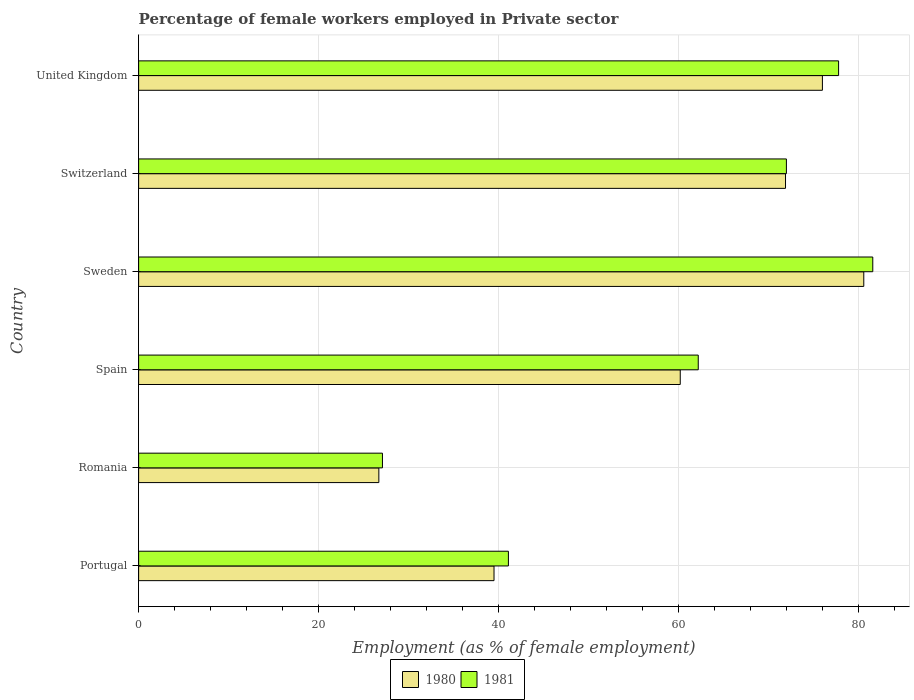How many groups of bars are there?
Give a very brief answer. 6. Are the number of bars on each tick of the Y-axis equal?
Your response must be concise. Yes. How many bars are there on the 3rd tick from the bottom?
Keep it short and to the point. 2. What is the label of the 5th group of bars from the top?
Provide a succinct answer. Romania. Across all countries, what is the maximum percentage of females employed in Private sector in 1981?
Offer a very short reply. 81.6. Across all countries, what is the minimum percentage of females employed in Private sector in 1981?
Ensure brevity in your answer.  27.1. In which country was the percentage of females employed in Private sector in 1980 maximum?
Provide a short and direct response. Sweden. In which country was the percentage of females employed in Private sector in 1981 minimum?
Your answer should be very brief. Romania. What is the total percentage of females employed in Private sector in 1980 in the graph?
Keep it short and to the point. 354.9. What is the difference between the percentage of females employed in Private sector in 1981 in Switzerland and that in United Kingdom?
Provide a succinct answer. -5.8. What is the difference between the percentage of females employed in Private sector in 1981 in Romania and the percentage of females employed in Private sector in 1980 in United Kingdom?
Offer a very short reply. -48.9. What is the average percentage of females employed in Private sector in 1980 per country?
Your response must be concise. 59.15. What is the difference between the percentage of females employed in Private sector in 1981 and percentage of females employed in Private sector in 1980 in Romania?
Provide a short and direct response. 0.4. In how many countries, is the percentage of females employed in Private sector in 1980 greater than 72 %?
Your answer should be compact. 2. What is the ratio of the percentage of females employed in Private sector in 1981 in Romania to that in United Kingdom?
Your response must be concise. 0.35. Is the difference between the percentage of females employed in Private sector in 1981 in Spain and Sweden greater than the difference between the percentage of females employed in Private sector in 1980 in Spain and Sweden?
Provide a succinct answer. Yes. What is the difference between the highest and the second highest percentage of females employed in Private sector in 1980?
Your response must be concise. 4.6. What is the difference between the highest and the lowest percentage of females employed in Private sector in 1980?
Your answer should be very brief. 53.9. In how many countries, is the percentage of females employed in Private sector in 1981 greater than the average percentage of females employed in Private sector in 1981 taken over all countries?
Make the answer very short. 4. What does the 1st bar from the bottom in Romania represents?
Your answer should be compact. 1980. How many bars are there?
Your answer should be very brief. 12. Are all the bars in the graph horizontal?
Ensure brevity in your answer.  Yes. How many countries are there in the graph?
Ensure brevity in your answer.  6. What is the difference between two consecutive major ticks on the X-axis?
Your answer should be very brief. 20. Does the graph contain any zero values?
Keep it short and to the point. No. Does the graph contain grids?
Your response must be concise. Yes. Where does the legend appear in the graph?
Give a very brief answer. Bottom center. How are the legend labels stacked?
Your answer should be compact. Horizontal. What is the title of the graph?
Make the answer very short. Percentage of female workers employed in Private sector. Does "2001" appear as one of the legend labels in the graph?
Your answer should be very brief. No. What is the label or title of the X-axis?
Ensure brevity in your answer.  Employment (as % of female employment). What is the Employment (as % of female employment) of 1980 in Portugal?
Offer a terse response. 39.5. What is the Employment (as % of female employment) of 1981 in Portugal?
Give a very brief answer. 41.1. What is the Employment (as % of female employment) in 1980 in Romania?
Provide a succinct answer. 26.7. What is the Employment (as % of female employment) of 1981 in Romania?
Offer a very short reply. 27.1. What is the Employment (as % of female employment) of 1980 in Spain?
Provide a short and direct response. 60.2. What is the Employment (as % of female employment) of 1981 in Spain?
Keep it short and to the point. 62.2. What is the Employment (as % of female employment) of 1980 in Sweden?
Offer a terse response. 80.6. What is the Employment (as % of female employment) of 1981 in Sweden?
Your response must be concise. 81.6. What is the Employment (as % of female employment) of 1980 in Switzerland?
Make the answer very short. 71.9. What is the Employment (as % of female employment) in 1980 in United Kingdom?
Ensure brevity in your answer.  76. What is the Employment (as % of female employment) of 1981 in United Kingdom?
Ensure brevity in your answer.  77.8. Across all countries, what is the maximum Employment (as % of female employment) in 1980?
Offer a terse response. 80.6. Across all countries, what is the maximum Employment (as % of female employment) of 1981?
Keep it short and to the point. 81.6. Across all countries, what is the minimum Employment (as % of female employment) in 1980?
Provide a succinct answer. 26.7. Across all countries, what is the minimum Employment (as % of female employment) of 1981?
Your answer should be compact. 27.1. What is the total Employment (as % of female employment) in 1980 in the graph?
Offer a very short reply. 354.9. What is the total Employment (as % of female employment) of 1981 in the graph?
Make the answer very short. 361.8. What is the difference between the Employment (as % of female employment) of 1981 in Portugal and that in Romania?
Ensure brevity in your answer.  14. What is the difference between the Employment (as % of female employment) in 1980 in Portugal and that in Spain?
Your answer should be very brief. -20.7. What is the difference between the Employment (as % of female employment) of 1981 in Portugal and that in Spain?
Make the answer very short. -21.1. What is the difference between the Employment (as % of female employment) in 1980 in Portugal and that in Sweden?
Offer a terse response. -41.1. What is the difference between the Employment (as % of female employment) in 1981 in Portugal and that in Sweden?
Give a very brief answer. -40.5. What is the difference between the Employment (as % of female employment) in 1980 in Portugal and that in Switzerland?
Provide a succinct answer. -32.4. What is the difference between the Employment (as % of female employment) of 1981 in Portugal and that in Switzerland?
Provide a short and direct response. -30.9. What is the difference between the Employment (as % of female employment) of 1980 in Portugal and that in United Kingdom?
Give a very brief answer. -36.5. What is the difference between the Employment (as % of female employment) in 1981 in Portugal and that in United Kingdom?
Provide a succinct answer. -36.7. What is the difference between the Employment (as % of female employment) in 1980 in Romania and that in Spain?
Your response must be concise. -33.5. What is the difference between the Employment (as % of female employment) of 1981 in Romania and that in Spain?
Provide a short and direct response. -35.1. What is the difference between the Employment (as % of female employment) in 1980 in Romania and that in Sweden?
Your answer should be compact. -53.9. What is the difference between the Employment (as % of female employment) of 1981 in Romania and that in Sweden?
Give a very brief answer. -54.5. What is the difference between the Employment (as % of female employment) of 1980 in Romania and that in Switzerland?
Your answer should be compact. -45.2. What is the difference between the Employment (as % of female employment) in 1981 in Romania and that in Switzerland?
Keep it short and to the point. -44.9. What is the difference between the Employment (as % of female employment) of 1980 in Romania and that in United Kingdom?
Offer a very short reply. -49.3. What is the difference between the Employment (as % of female employment) in 1981 in Romania and that in United Kingdom?
Provide a short and direct response. -50.7. What is the difference between the Employment (as % of female employment) in 1980 in Spain and that in Sweden?
Ensure brevity in your answer.  -20.4. What is the difference between the Employment (as % of female employment) of 1981 in Spain and that in Sweden?
Provide a succinct answer. -19.4. What is the difference between the Employment (as % of female employment) in 1980 in Spain and that in United Kingdom?
Give a very brief answer. -15.8. What is the difference between the Employment (as % of female employment) in 1981 in Spain and that in United Kingdom?
Offer a very short reply. -15.6. What is the difference between the Employment (as % of female employment) of 1981 in Sweden and that in Switzerland?
Give a very brief answer. 9.6. What is the difference between the Employment (as % of female employment) in 1980 in Sweden and that in United Kingdom?
Ensure brevity in your answer.  4.6. What is the difference between the Employment (as % of female employment) of 1981 in Sweden and that in United Kingdom?
Offer a very short reply. 3.8. What is the difference between the Employment (as % of female employment) in 1980 in Switzerland and that in United Kingdom?
Offer a very short reply. -4.1. What is the difference between the Employment (as % of female employment) in 1980 in Portugal and the Employment (as % of female employment) in 1981 in Romania?
Ensure brevity in your answer.  12.4. What is the difference between the Employment (as % of female employment) of 1980 in Portugal and the Employment (as % of female employment) of 1981 in Spain?
Give a very brief answer. -22.7. What is the difference between the Employment (as % of female employment) in 1980 in Portugal and the Employment (as % of female employment) in 1981 in Sweden?
Make the answer very short. -42.1. What is the difference between the Employment (as % of female employment) in 1980 in Portugal and the Employment (as % of female employment) in 1981 in Switzerland?
Your answer should be compact. -32.5. What is the difference between the Employment (as % of female employment) in 1980 in Portugal and the Employment (as % of female employment) in 1981 in United Kingdom?
Ensure brevity in your answer.  -38.3. What is the difference between the Employment (as % of female employment) in 1980 in Romania and the Employment (as % of female employment) in 1981 in Spain?
Ensure brevity in your answer.  -35.5. What is the difference between the Employment (as % of female employment) in 1980 in Romania and the Employment (as % of female employment) in 1981 in Sweden?
Your answer should be very brief. -54.9. What is the difference between the Employment (as % of female employment) in 1980 in Romania and the Employment (as % of female employment) in 1981 in Switzerland?
Provide a succinct answer. -45.3. What is the difference between the Employment (as % of female employment) in 1980 in Romania and the Employment (as % of female employment) in 1981 in United Kingdom?
Offer a terse response. -51.1. What is the difference between the Employment (as % of female employment) of 1980 in Spain and the Employment (as % of female employment) of 1981 in Sweden?
Offer a very short reply. -21.4. What is the difference between the Employment (as % of female employment) of 1980 in Spain and the Employment (as % of female employment) of 1981 in United Kingdom?
Provide a succinct answer. -17.6. What is the difference between the Employment (as % of female employment) in 1980 in Sweden and the Employment (as % of female employment) in 1981 in Switzerland?
Ensure brevity in your answer.  8.6. What is the difference between the Employment (as % of female employment) of 1980 in Sweden and the Employment (as % of female employment) of 1981 in United Kingdom?
Keep it short and to the point. 2.8. What is the difference between the Employment (as % of female employment) of 1980 in Switzerland and the Employment (as % of female employment) of 1981 in United Kingdom?
Your response must be concise. -5.9. What is the average Employment (as % of female employment) in 1980 per country?
Your answer should be compact. 59.15. What is the average Employment (as % of female employment) of 1981 per country?
Your response must be concise. 60.3. What is the difference between the Employment (as % of female employment) of 1980 and Employment (as % of female employment) of 1981 in Portugal?
Provide a succinct answer. -1.6. What is the difference between the Employment (as % of female employment) in 1980 and Employment (as % of female employment) in 1981 in Switzerland?
Keep it short and to the point. -0.1. What is the ratio of the Employment (as % of female employment) of 1980 in Portugal to that in Romania?
Provide a short and direct response. 1.48. What is the ratio of the Employment (as % of female employment) of 1981 in Portugal to that in Romania?
Offer a terse response. 1.52. What is the ratio of the Employment (as % of female employment) of 1980 in Portugal to that in Spain?
Your answer should be compact. 0.66. What is the ratio of the Employment (as % of female employment) of 1981 in Portugal to that in Spain?
Provide a succinct answer. 0.66. What is the ratio of the Employment (as % of female employment) of 1980 in Portugal to that in Sweden?
Your answer should be compact. 0.49. What is the ratio of the Employment (as % of female employment) of 1981 in Portugal to that in Sweden?
Your answer should be compact. 0.5. What is the ratio of the Employment (as % of female employment) in 1980 in Portugal to that in Switzerland?
Ensure brevity in your answer.  0.55. What is the ratio of the Employment (as % of female employment) of 1981 in Portugal to that in Switzerland?
Ensure brevity in your answer.  0.57. What is the ratio of the Employment (as % of female employment) of 1980 in Portugal to that in United Kingdom?
Provide a short and direct response. 0.52. What is the ratio of the Employment (as % of female employment) in 1981 in Portugal to that in United Kingdom?
Your response must be concise. 0.53. What is the ratio of the Employment (as % of female employment) in 1980 in Romania to that in Spain?
Your response must be concise. 0.44. What is the ratio of the Employment (as % of female employment) of 1981 in Romania to that in Spain?
Provide a short and direct response. 0.44. What is the ratio of the Employment (as % of female employment) of 1980 in Romania to that in Sweden?
Give a very brief answer. 0.33. What is the ratio of the Employment (as % of female employment) of 1981 in Romania to that in Sweden?
Your response must be concise. 0.33. What is the ratio of the Employment (as % of female employment) of 1980 in Romania to that in Switzerland?
Your answer should be compact. 0.37. What is the ratio of the Employment (as % of female employment) in 1981 in Romania to that in Switzerland?
Offer a terse response. 0.38. What is the ratio of the Employment (as % of female employment) in 1980 in Romania to that in United Kingdom?
Offer a terse response. 0.35. What is the ratio of the Employment (as % of female employment) of 1981 in Romania to that in United Kingdom?
Keep it short and to the point. 0.35. What is the ratio of the Employment (as % of female employment) of 1980 in Spain to that in Sweden?
Give a very brief answer. 0.75. What is the ratio of the Employment (as % of female employment) of 1981 in Spain to that in Sweden?
Give a very brief answer. 0.76. What is the ratio of the Employment (as % of female employment) in 1980 in Spain to that in Switzerland?
Ensure brevity in your answer.  0.84. What is the ratio of the Employment (as % of female employment) in 1981 in Spain to that in Switzerland?
Your answer should be very brief. 0.86. What is the ratio of the Employment (as % of female employment) of 1980 in Spain to that in United Kingdom?
Provide a succinct answer. 0.79. What is the ratio of the Employment (as % of female employment) of 1981 in Spain to that in United Kingdom?
Your answer should be compact. 0.8. What is the ratio of the Employment (as % of female employment) in 1980 in Sweden to that in Switzerland?
Offer a terse response. 1.12. What is the ratio of the Employment (as % of female employment) in 1981 in Sweden to that in Switzerland?
Provide a short and direct response. 1.13. What is the ratio of the Employment (as % of female employment) in 1980 in Sweden to that in United Kingdom?
Your answer should be very brief. 1.06. What is the ratio of the Employment (as % of female employment) of 1981 in Sweden to that in United Kingdom?
Make the answer very short. 1.05. What is the ratio of the Employment (as % of female employment) in 1980 in Switzerland to that in United Kingdom?
Offer a terse response. 0.95. What is the ratio of the Employment (as % of female employment) in 1981 in Switzerland to that in United Kingdom?
Make the answer very short. 0.93. What is the difference between the highest and the second highest Employment (as % of female employment) of 1980?
Your answer should be very brief. 4.6. What is the difference between the highest and the lowest Employment (as % of female employment) in 1980?
Your answer should be compact. 53.9. What is the difference between the highest and the lowest Employment (as % of female employment) in 1981?
Offer a very short reply. 54.5. 